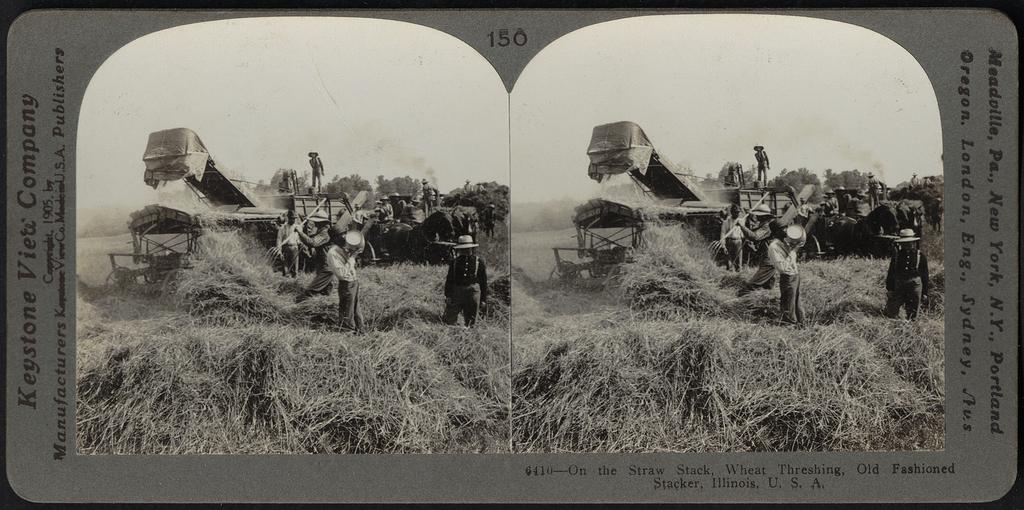What number is the image slide?
Provide a succinct answer. 150. What is the company name?
Ensure brevity in your answer.  Keystone view company. 